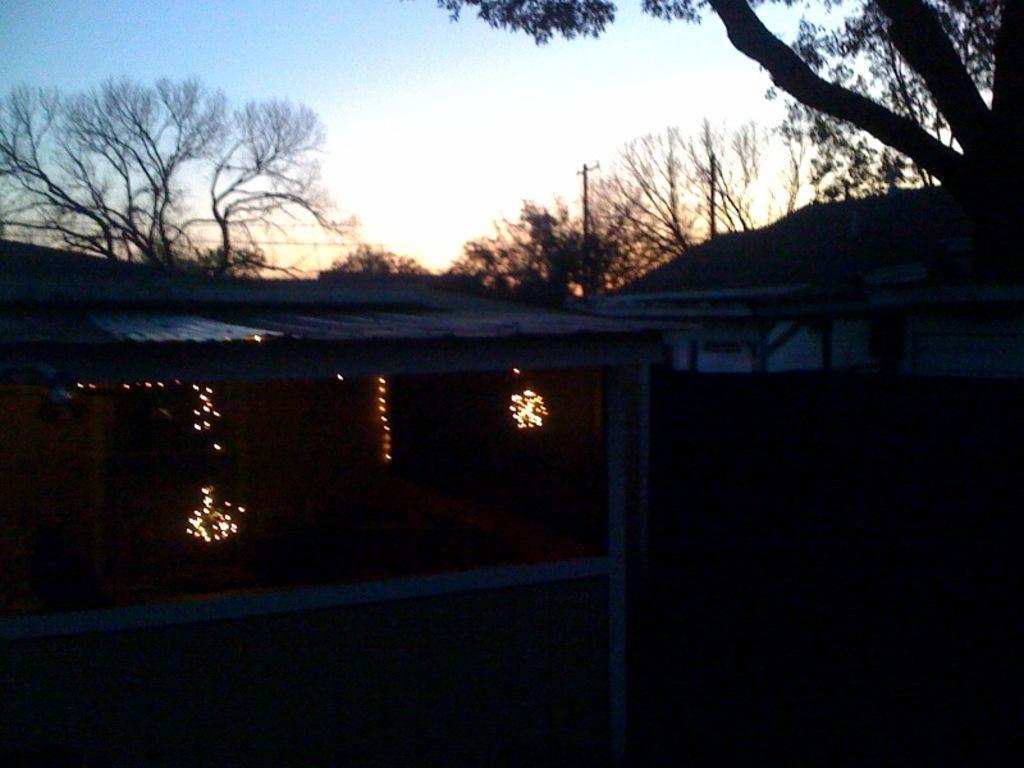Please provide a concise description of this image. In this picture there are few lightnings and there are trees in the background. 